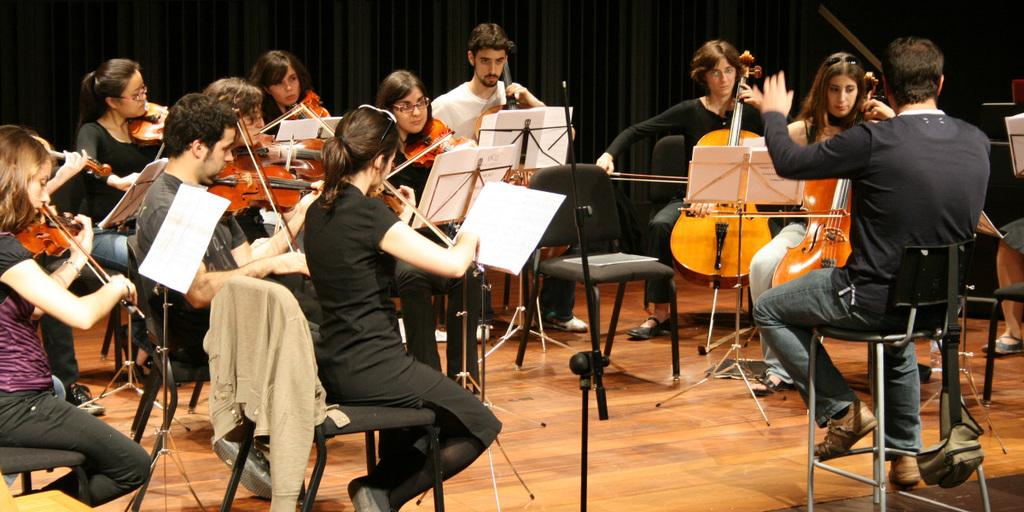What is happening in the image? There is a group of people in the image, and they are playing musical instruments. What are the people doing in the image? The people are playing musical instruments. What direction is the clam facing in the image? There is no clam present in the image. How many roses are being played by the group of people in the image? There are no roses present in the image; the group of people is playing musical instruments. 